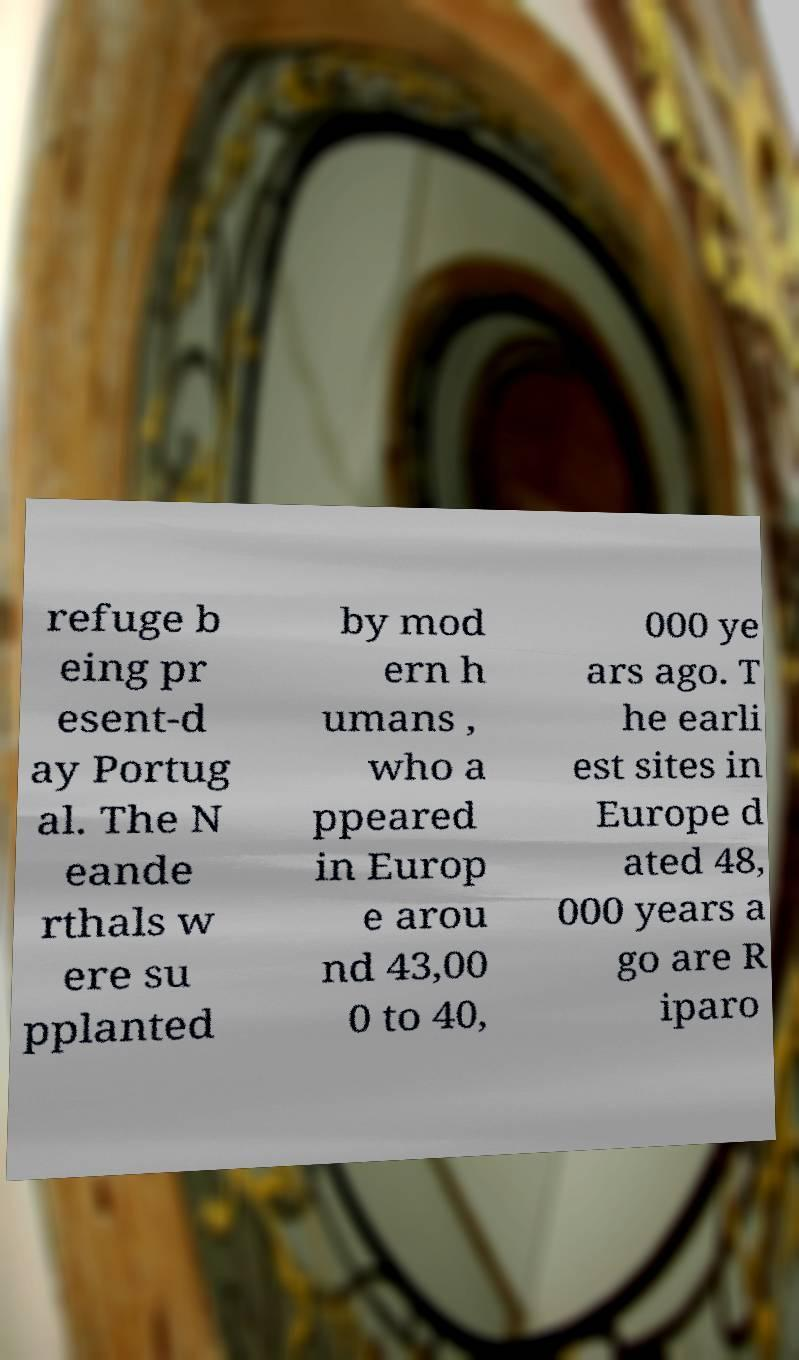Can you read and provide the text displayed in the image?This photo seems to have some interesting text. Can you extract and type it out for me? refuge b eing pr esent-d ay Portug al. The N eande rthals w ere su pplanted by mod ern h umans , who a ppeared in Europ e arou nd 43,00 0 to 40, 000 ye ars ago. T he earli est sites in Europe d ated 48, 000 years a go are R iparo 